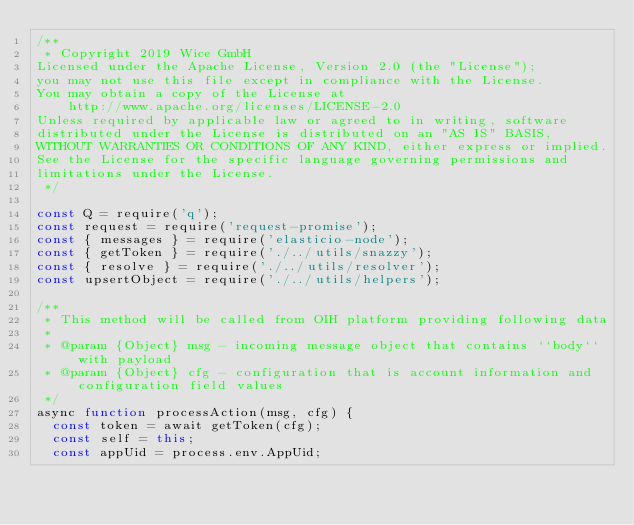<code> <loc_0><loc_0><loc_500><loc_500><_JavaScript_>/**
 * Copyright 2019 Wice GmbH
Licensed under the Apache License, Version 2.0 (the "License");
you may not use this file except in compliance with the License.
You may obtain a copy of the License at
    http://www.apache.org/licenses/LICENSE-2.0
Unless required by applicable law or agreed to in writing, software
distributed under the License is distributed on an "AS IS" BASIS,
WITHOUT WARRANTIES OR CONDITIONS OF ANY KIND, either express or implied.
See the License for the specific language governing permissions and
limitations under the License.
 */

const Q = require('q');
const request = require('request-promise');
const { messages } = require('elasticio-node');
const { getToken } = require('./../utils/snazzy');
const { resolve } = require('./../utils/resolver');
const upsertObject = require('./../utils/helpers');

/**
 * This method will be called from OIH platform providing following data
 *
 * @param {Object} msg - incoming message object that contains ``body`` with payload
 * @param {Object} cfg - configuration that is account information and configuration field values
 */
async function processAction(msg, cfg) {
  const token = await getToken(cfg);
  const self = this;
  const appUid = process.env.AppUid;</code> 